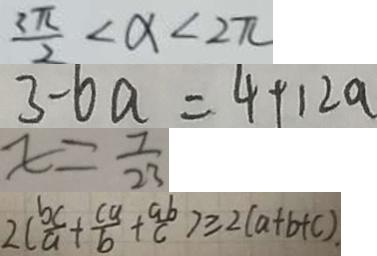Convert formula to latex. <formula><loc_0><loc_0><loc_500><loc_500>\frac { 2 \pi } { 2 } < \alpha < 2 \pi 
 3 - 6 a = 4 + 1 2 a 
 x = \frac { 7 } { 2 3 } 
 2 ( \frac { b c } { a } + \frac { c a } { b } + \frac { a b } { c } ) \geq 2 ( a + b + c )</formula> 